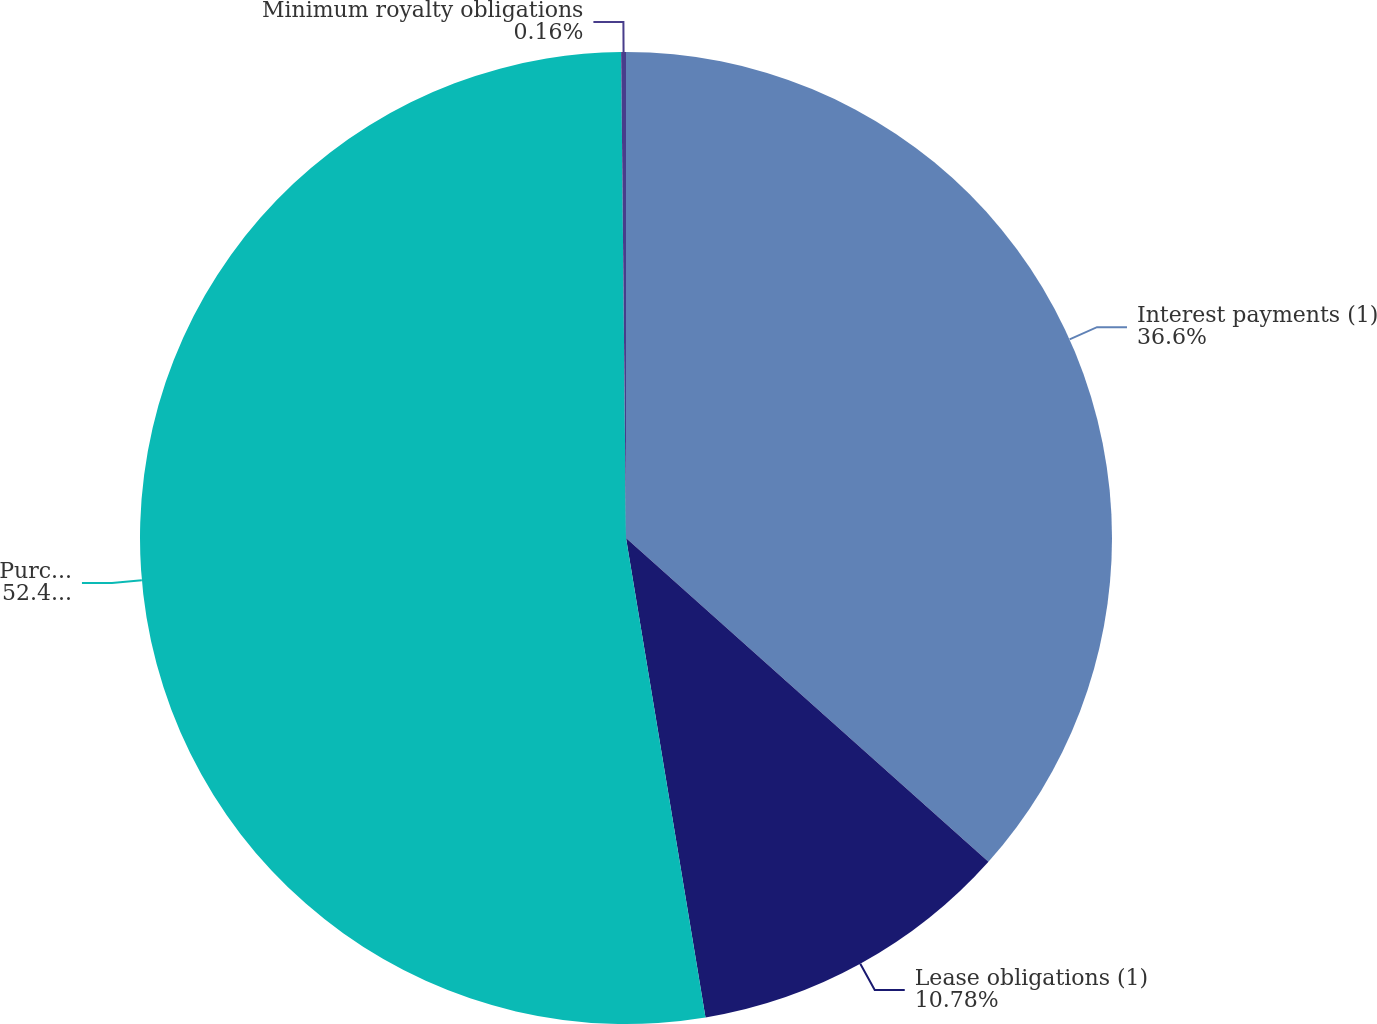Convert chart to OTSL. <chart><loc_0><loc_0><loc_500><loc_500><pie_chart><fcel>Interest payments (1)<fcel>Lease obligations (1)<fcel>Purchase obligations (1)<fcel>Minimum royalty obligations<nl><fcel>36.6%<fcel>10.78%<fcel>52.45%<fcel>0.16%<nl></chart> 